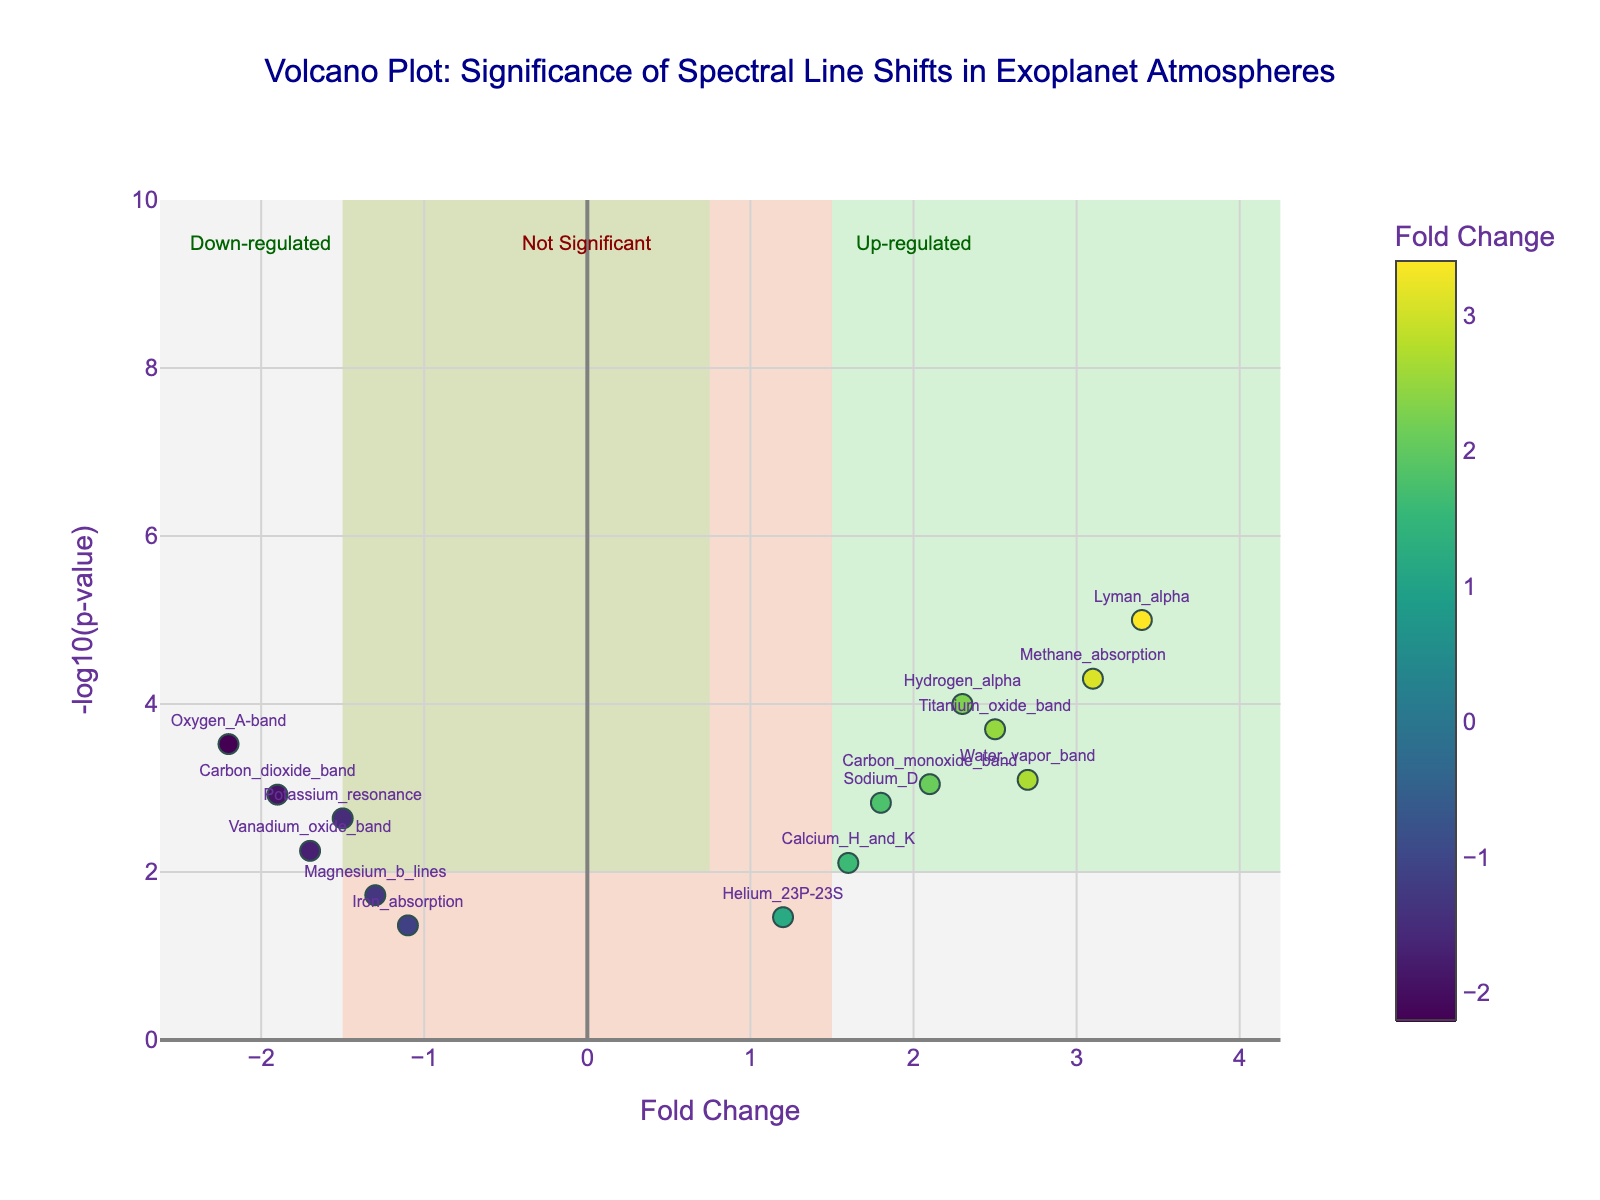What is the spectral line with the highest fold change? First, identify the x-axis labeled as "Fold Change" and find the point furthest to the right. The spectral line with this point is labeled "Lyman_alpha".
Answer: Lyman_alpha What is the y-axis label of the plot? Look at the label on the vertical axis. It is displayed as "-log10(p-value)".
Answer: -log10(p-value) How many data points fall within the "Not Significant" shaded region? The "Not Significant" region is shaded in LightSalmon and covers -1.5 to 1.5 on the x-axis and below 2 on the y-axis. Count the points within this area. There are three: Helium_23P-23S, Magnesium_b_lines, and Iron_absorption.
Answer: 3 Which spectral line has the lowest p-value, and what is its value? To find the lowest p-value, locate the highest point on the y-axis ("-log10(p-value)"). This point is labeled "Lyman_alpha". Referring to the hover text, the p-value for "Lyman_alpha" is 0.00001.
Answer: Lyman_alpha, 0.00001 Are there more up-regulated or down-regulated spectral lines? Count the points in both the up-regulated (fold change > 1.5) and down-regulated (fold change < -1.5) regions, both shaded in LightGreen. There are five up-regulated and four down-regulated spectral lines.
Answer: More up-regulated Which spectral lines are considered significant? Significant lines fall outside the "Not Significant" region (fold change > 1.5 or < -1.5 and -log10(p-value) > 2). These are Hydrogen_alpha, Methane_absorption, Water_vapor_band, Carbon_dioxide_band, Oxygen_A-band, Titanium_oxide_band, Lyman_alpha, and Carbon_monoxide_band.
Answer: Hydrogen_alpha, Methane_absorption, Water_vapor_band, Carbon_dioxide_band, Oxygen_A-band, Titanium_oxide_band, Lyman_alpha, Carbon_monoxide_band What is the fold change of the "Oxygen_A-band"? Find the point labeled "Oxygen_A-band" and read its position on the x-axis. Its fold change is -2.2.
Answer: -2.2 How many spectral lines have a fold change greater than 2.0? Count the points with fold changes greater than 2.0 on the x-axis. There are four: Hydrogen_alpha, Methane_absorption, Water_vapor_band, and Lyman_alpha.
Answer: 4 